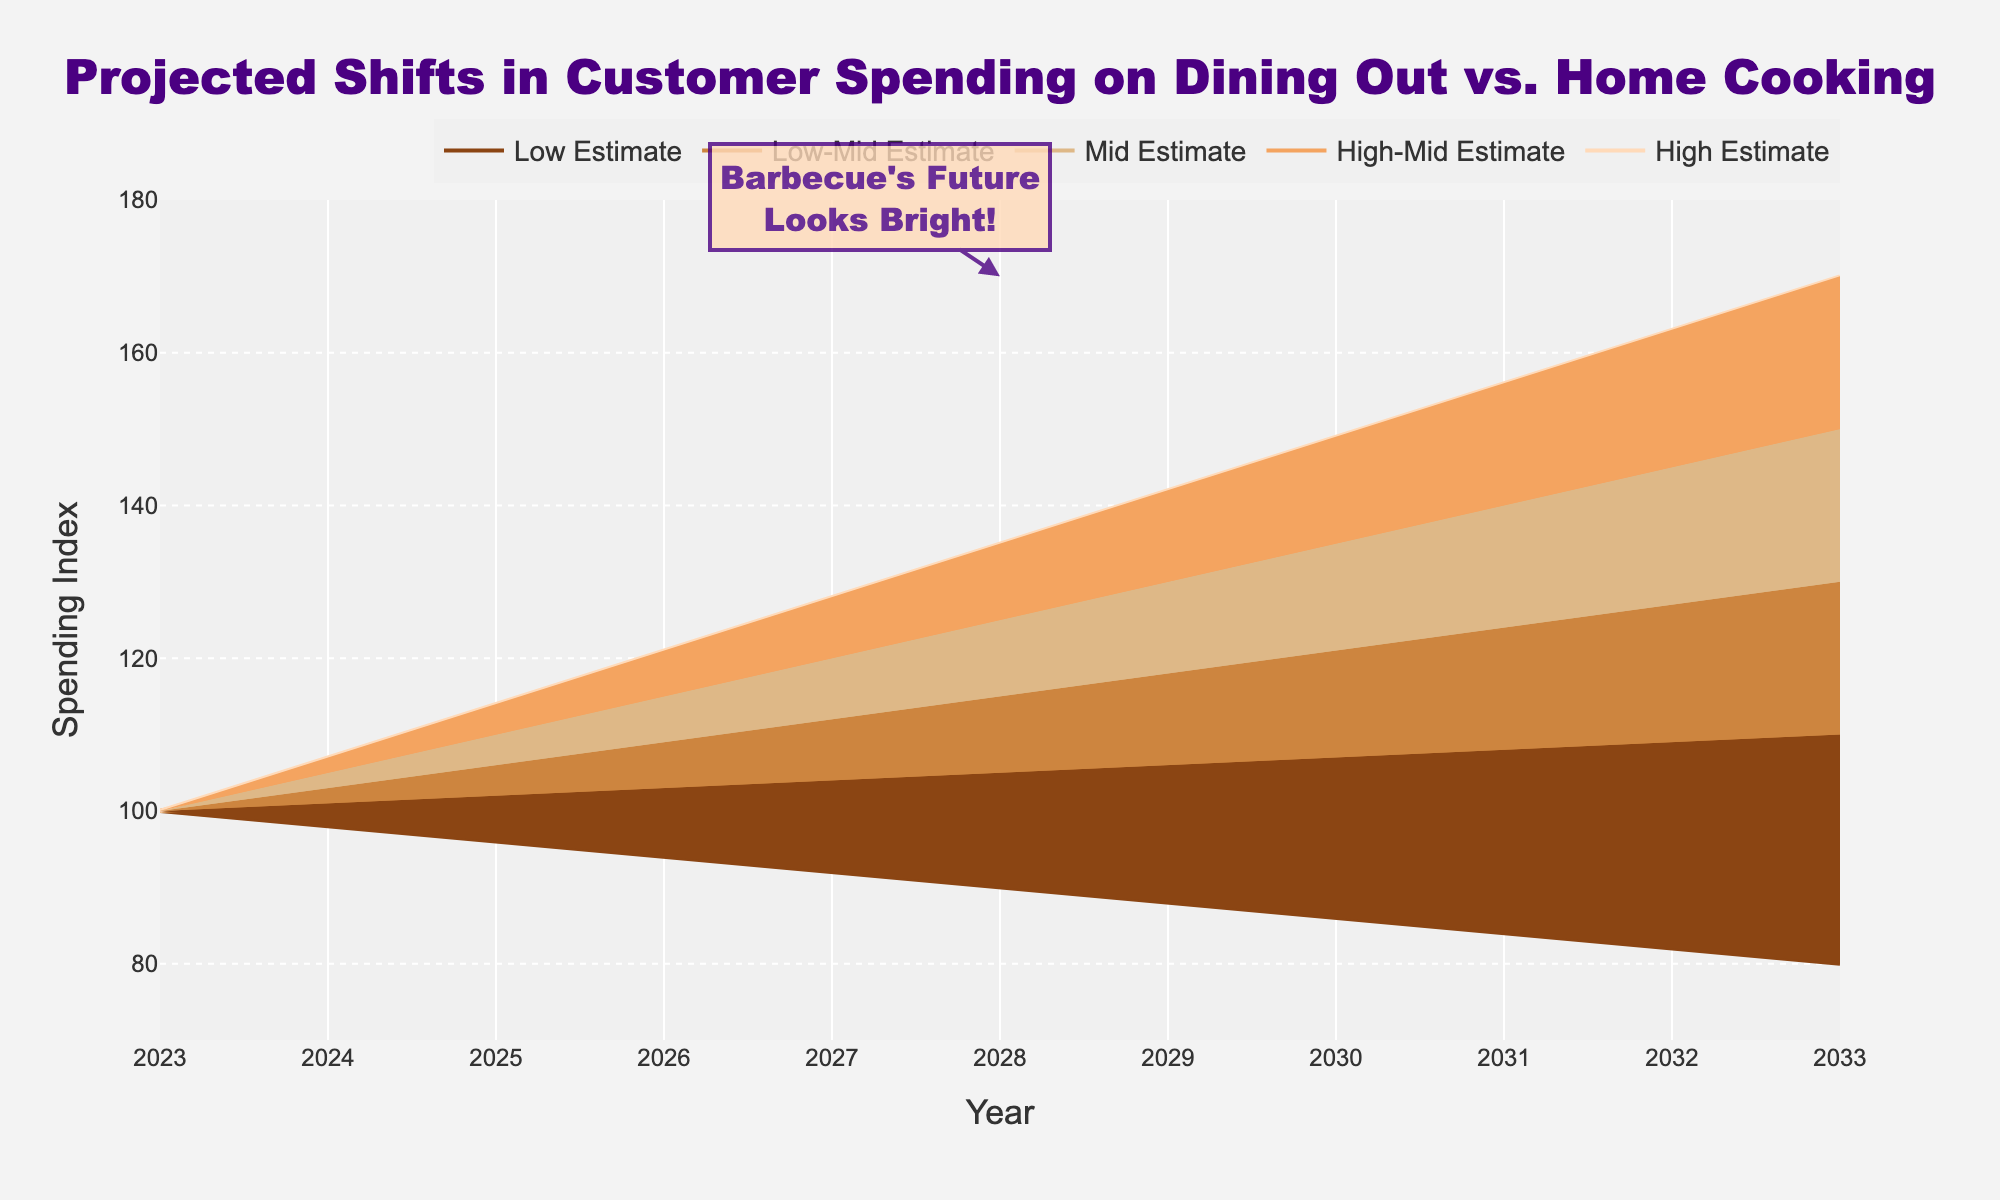what is the title of the figure? The title is displayed at the top of the figure, reading "Projected Shifts in Customer Spending on Dining Out vs. Home Cooking".
Answer: Projected Shifts in Customer Spending on Dining Out vs. Home Cooking What are the five estimates shown on the plot? Five lines on the plot are labeled as Low Estimate, Low-Mid Estimate, Mid Estimate, High-Mid Estimate, and High Estimate.
Answer: Low Estimate, Low-Mid Estimate, Mid Estimate, High-Mid Estimate, High Estimate What colors are used to represent the different estimates? The colors used are different shades of brown and peach, ranging from dark brown for Low Estimate to peach for High Estimate.
Answer: Shades of brown and peach How does the Mid Estimate trend from 2023 to 2033? Looking at the Mid Estimate line, it starts at 100 in 2023 and rises progressively to 130 by 2033.
Answer: It increases By how much is the High Estimate projected to increase from 2023 to 2033? The High Estimate starts at 100 in 2023 and reaches 170 by 2033, showing an increase of 70 points.
Answer: 70 points In which year is the difference between the Low and High Estimates the greatest? The difference between the Low and High Estimates increases each year, reaching its maximum in 2033 where the Low Estimate is 80 and the High Estimate is 170, making a difference of 90 points.
Answer: 2033 What is the average value of the Mid Estimate between 2023 and 2033? The Mid Estimate values between 2023 and 2033 are: 100, 103, 106, 109, 112, 115, 118, 121, 124, 127, 130. Adding these up gives 1265, and dividing by the 11 years gives an average of roughly 115.
Answer: 115 Does the annotation suggest a positive or negative outlook for barbecue’s future? The annotation states "Barbecue's Future Looks Bright!", indicating a positive outlook.
Answer: Positive During which year does the High Estimate reach 140? By following the High Estimate line, it reaches 140 in 2031.
Answer: 2031 Which estimate shows the least amount of change over the projection period? The Low Estimate shows the least amount of change, starting at 100 in 2023 and decreasing gradually to 80 in 2033.
Answer: Low Estimate 